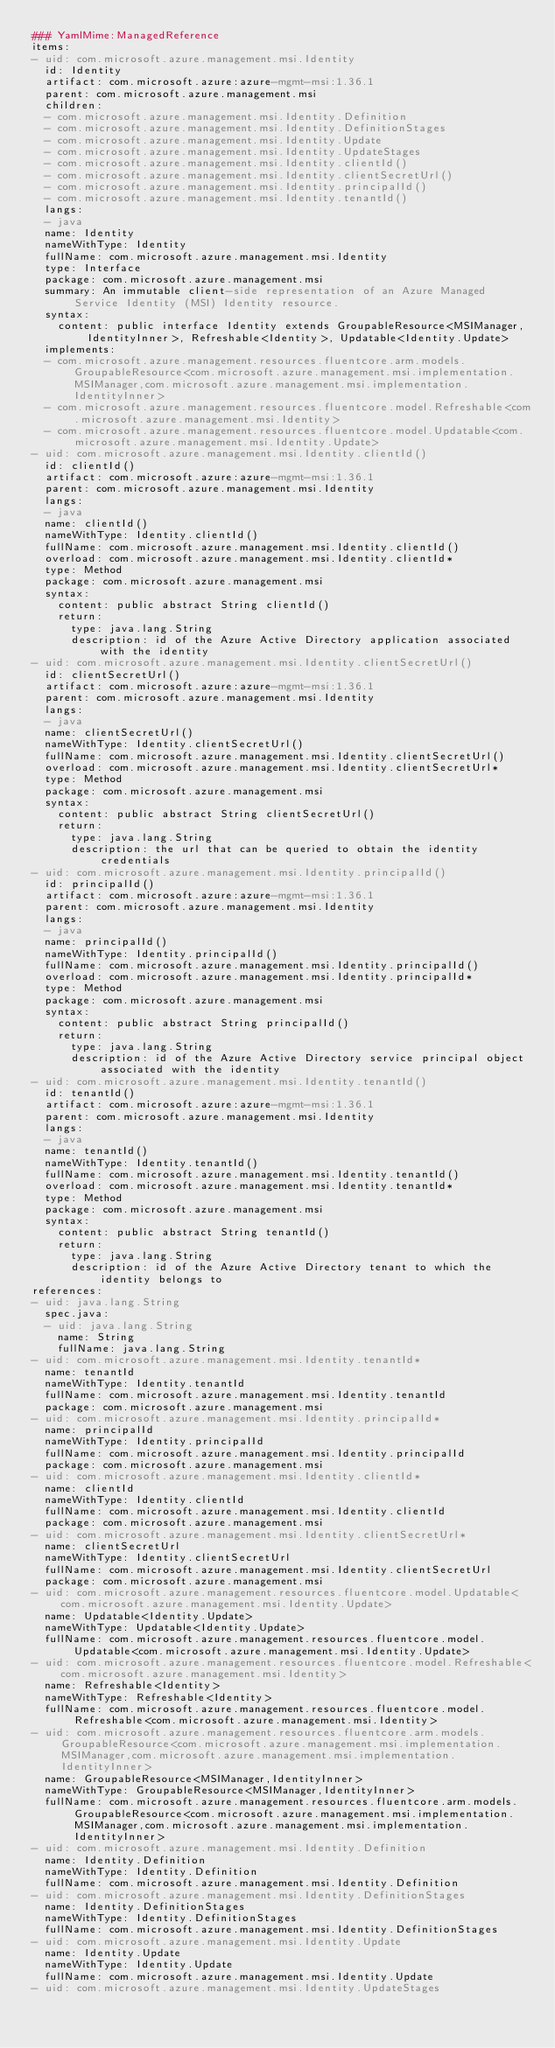<code> <loc_0><loc_0><loc_500><loc_500><_YAML_>### YamlMime:ManagedReference
items:
- uid: com.microsoft.azure.management.msi.Identity
  id: Identity
  artifact: com.microsoft.azure:azure-mgmt-msi:1.36.1
  parent: com.microsoft.azure.management.msi
  children:
  - com.microsoft.azure.management.msi.Identity.Definition
  - com.microsoft.azure.management.msi.Identity.DefinitionStages
  - com.microsoft.azure.management.msi.Identity.Update
  - com.microsoft.azure.management.msi.Identity.UpdateStages
  - com.microsoft.azure.management.msi.Identity.clientId()
  - com.microsoft.azure.management.msi.Identity.clientSecretUrl()
  - com.microsoft.azure.management.msi.Identity.principalId()
  - com.microsoft.azure.management.msi.Identity.tenantId()
  langs:
  - java
  name: Identity
  nameWithType: Identity
  fullName: com.microsoft.azure.management.msi.Identity
  type: Interface
  package: com.microsoft.azure.management.msi
  summary: An immutable client-side representation of an Azure Managed Service Identity (MSI) Identity resource.
  syntax:
    content: public interface Identity extends GroupableResource<MSIManager,IdentityInner>, Refreshable<Identity>, Updatable<Identity.Update>
  implements:
  - com.microsoft.azure.management.resources.fluentcore.arm.models.GroupableResource<com.microsoft.azure.management.msi.implementation.MSIManager,com.microsoft.azure.management.msi.implementation.IdentityInner>
  - com.microsoft.azure.management.resources.fluentcore.model.Refreshable<com.microsoft.azure.management.msi.Identity>
  - com.microsoft.azure.management.resources.fluentcore.model.Updatable<com.microsoft.azure.management.msi.Identity.Update>
- uid: com.microsoft.azure.management.msi.Identity.clientId()
  id: clientId()
  artifact: com.microsoft.azure:azure-mgmt-msi:1.36.1
  parent: com.microsoft.azure.management.msi.Identity
  langs:
  - java
  name: clientId()
  nameWithType: Identity.clientId()
  fullName: com.microsoft.azure.management.msi.Identity.clientId()
  overload: com.microsoft.azure.management.msi.Identity.clientId*
  type: Method
  package: com.microsoft.azure.management.msi
  syntax:
    content: public abstract String clientId()
    return:
      type: java.lang.String
      description: id of the Azure Active Directory application associated with the identity
- uid: com.microsoft.azure.management.msi.Identity.clientSecretUrl()
  id: clientSecretUrl()
  artifact: com.microsoft.azure:azure-mgmt-msi:1.36.1
  parent: com.microsoft.azure.management.msi.Identity
  langs:
  - java
  name: clientSecretUrl()
  nameWithType: Identity.clientSecretUrl()
  fullName: com.microsoft.azure.management.msi.Identity.clientSecretUrl()
  overload: com.microsoft.azure.management.msi.Identity.clientSecretUrl*
  type: Method
  package: com.microsoft.azure.management.msi
  syntax:
    content: public abstract String clientSecretUrl()
    return:
      type: java.lang.String
      description: the url that can be queried to obtain the identity credentials
- uid: com.microsoft.azure.management.msi.Identity.principalId()
  id: principalId()
  artifact: com.microsoft.azure:azure-mgmt-msi:1.36.1
  parent: com.microsoft.azure.management.msi.Identity
  langs:
  - java
  name: principalId()
  nameWithType: Identity.principalId()
  fullName: com.microsoft.azure.management.msi.Identity.principalId()
  overload: com.microsoft.azure.management.msi.Identity.principalId*
  type: Method
  package: com.microsoft.azure.management.msi
  syntax:
    content: public abstract String principalId()
    return:
      type: java.lang.String
      description: id of the Azure Active Directory service principal object associated with the identity
- uid: com.microsoft.azure.management.msi.Identity.tenantId()
  id: tenantId()
  artifact: com.microsoft.azure:azure-mgmt-msi:1.36.1
  parent: com.microsoft.azure.management.msi.Identity
  langs:
  - java
  name: tenantId()
  nameWithType: Identity.tenantId()
  fullName: com.microsoft.azure.management.msi.Identity.tenantId()
  overload: com.microsoft.azure.management.msi.Identity.tenantId*
  type: Method
  package: com.microsoft.azure.management.msi
  syntax:
    content: public abstract String tenantId()
    return:
      type: java.lang.String
      description: id of the Azure Active Directory tenant to which the identity belongs to
references:
- uid: java.lang.String
  spec.java:
  - uid: java.lang.String
    name: String
    fullName: java.lang.String
- uid: com.microsoft.azure.management.msi.Identity.tenantId*
  name: tenantId
  nameWithType: Identity.tenantId
  fullName: com.microsoft.azure.management.msi.Identity.tenantId
  package: com.microsoft.azure.management.msi
- uid: com.microsoft.azure.management.msi.Identity.principalId*
  name: principalId
  nameWithType: Identity.principalId
  fullName: com.microsoft.azure.management.msi.Identity.principalId
  package: com.microsoft.azure.management.msi
- uid: com.microsoft.azure.management.msi.Identity.clientId*
  name: clientId
  nameWithType: Identity.clientId
  fullName: com.microsoft.azure.management.msi.Identity.clientId
  package: com.microsoft.azure.management.msi
- uid: com.microsoft.azure.management.msi.Identity.clientSecretUrl*
  name: clientSecretUrl
  nameWithType: Identity.clientSecretUrl
  fullName: com.microsoft.azure.management.msi.Identity.clientSecretUrl
  package: com.microsoft.azure.management.msi
- uid: com.microsoft.azure.management.resources.fluentcore.model.Updatable<com.microsoft.azure.management.msi.Identity.Update>
  name: Updatable<Identity.Update>
  nameWithType: Updatable<Identity.Update>
  fullName: com.microsoft.azure.management.resources.fluentcore.model.Updatable<com.microsoft.azure.management.msi.Identity.Update>
- uid: com.microsoft.azure.management.resources.fluentcore.model.Refreshable<com.microsoft.azure.management.msi.Identity>
  name: Refreshable<Identity>
  nameWithType: Refreshable<Identity>
  fullName: com.microsoft.azure.management.resources.fluentcore.model.Refreshable<com.microsoft.azure.management.msi.Identity>
- uid: com.microsoft.azure.management.resources.fluentcore.arm.models.GroupableResource<com.microsoft.azure.management.msi.implementation.MSIManager,com.microsoft.azure.management.msi.implementation.IdentityInner>
  name: GroupableResource<MSIManager,IdentityInner>
  nameWithType: GroupableResource<MSIManager,IdentityInner>
  fullName: com.microsoft.azure.management.resources.fluentcore.arm.models.GroupableResource<com.microsoft.azure.management.msi.implementation.MSIManager,com.microsoft.azure.management.msi.implementation.IdentityInner>
- uid: com.microsoft.azure.management.msi.Identity.Definition
  name: Identity.Definition
  nameWithType: Identity.Definition
  fullName: com.microsoft.azure.management.msi.Identity.Definition
- uid: com.microsoft.azure.management.msi.Identity.DefinitionStages
  name: Identity.DefinitionStages
  nameWithType: Identity.DefinitionStages
  fullName: com.microsoft.azure.management.msi.Identity.DefinitionStages
- uid: com.microsoft.azure.management.msi.Identity.Update
  name: Identity.Update
  nameWithType: Identity.Update
  fullName: com.microsoft.azure.management.msi.Identity.Update
- uid: com.microsoft.azure.management.msi.Identity.UpdateStages</code> 